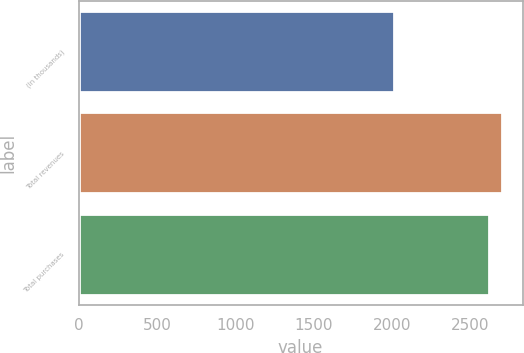<chart> <loc_0><loc_0><loc_500><loc_500><bar_chart><fcel>(In thousands)<fcel>Total revenues<fcel>Total purchases<nl><fcel>2014<fcel>2701<fcel>2622<nl></chart> 